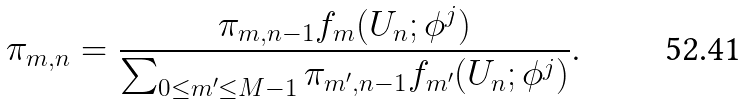<formula> <loc_0><loc_0><loc_500><loc_500>\pi _ { m , n } = \frac { \pi _ { m , n - 1 } f _ { m } ( U _ { n } ; \phi ^ { j } ) } { \sum _ { 0 \leq m ^ { \prime } \leq M - 1 } \pi _ { m ^ { \prime } , n - 1 } f _ { m ^ { \prime } } ( U _ { n } ; \phi ^ { j } ) } .</formula> 